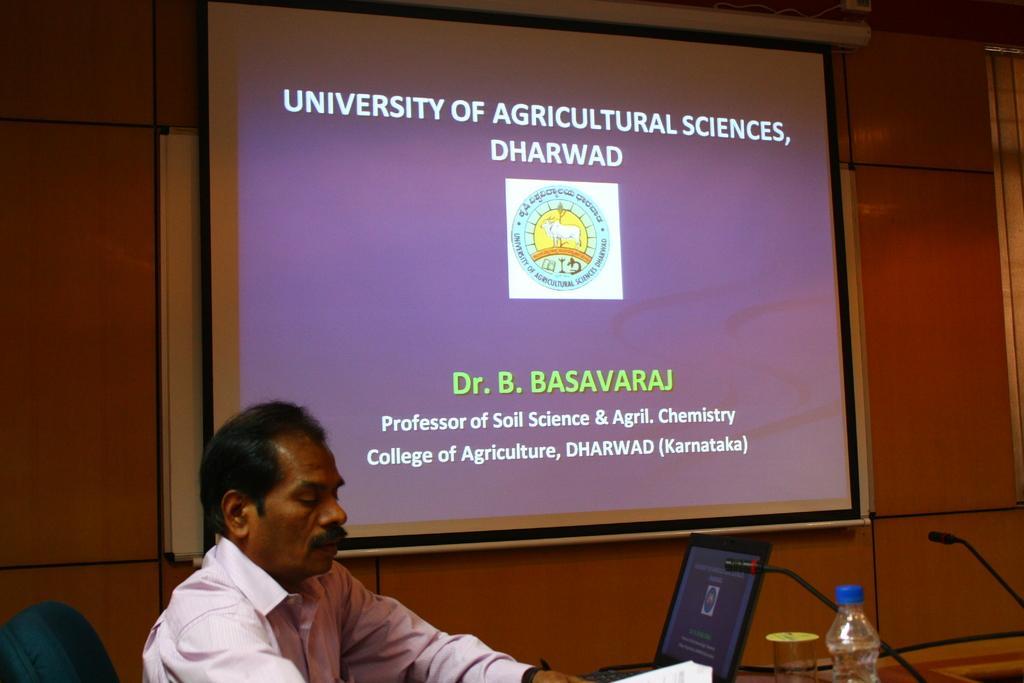<image>
Give a short and clear explanation of the subsequent image. A man sitting in a blue chair that is looking at some papers and is presenting a PowerPoint titled University of Agricultural Sciences, Dharwad. 